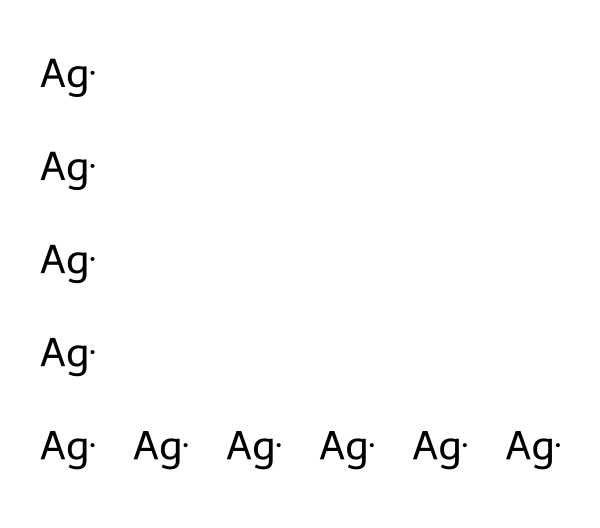How many silver atoms are present in the structure? The SMILES representation shows ten instances of the silver atom (Ag). Each "Ag" denotes one silver atom. Counting them, we arrive at ten.
Answer: ten What is the primary element in this chemical structure? The SMILES representation consists solely of silver atoms. Since silver is the only element present, it is the primary element in the structure.
Answer: silver Does this structure exhibit bonding between different types of atoms? The structure only shows silver atoms, with no other elements indicated. Therefore, there are no bonds between different types of atoms in this representation.
Answer: no What is the chemical significance of using nanosilver in coatings? Nanosilver is known for its antimicrobial properties, which are beneficial in applications such as coatings, especially in government facilities requiring high hygiene standards.
Answer: antimicrobial properties How does the particle size of nanosilver affect its antimicrobial activity? Nanosilver's small particle size increases its surface area, enhancing its interaction with microorganisms, which leads to greater efficacy in antimicrobial applications.
Answer: increased efficacy What type of nanomaterial is represented by this structure? The structure represents a type of nanomaterial known as nanoparticles, specifically metallic nanoparticles, because it consists exclusively of silver atoms at the nanoscale.
Answer: metallic nanoparticles What potential applications does nanosilver have in government facilities? Nanosilver is commonly used in coatings and materials that require antimicrobial properties, such as in healthcare settings, water purification, and public spaces to minimize infections.
Answer: antimicrobial coatings 